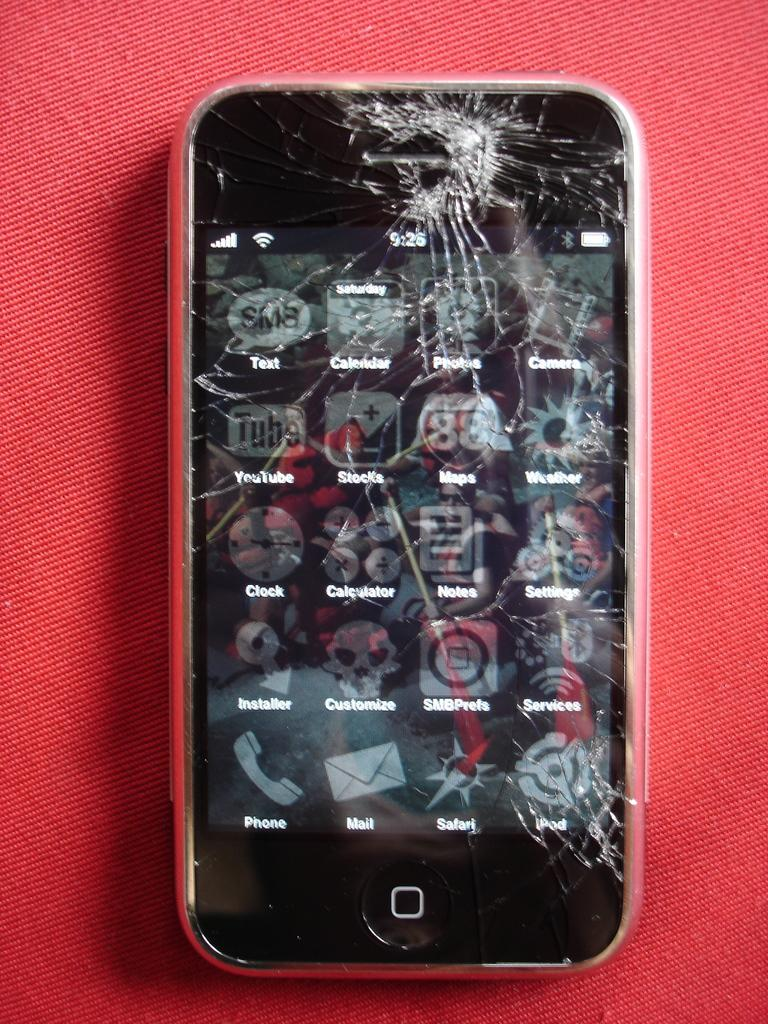<image>
Describe the image concisely. phone with cracked screen showing several apps including safari, ipod, and youtube 